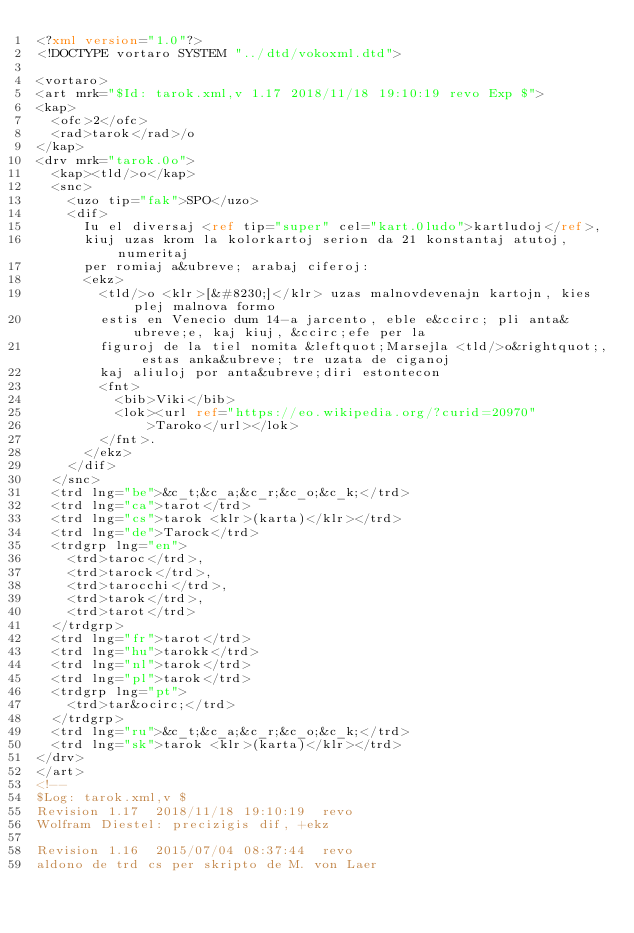Convert code to text. <code><loc_0><loc_0><loc_500><loc_500><_XML_><?xml version="1.0"?>
<!DOCTYPE vortaro SYSTEM "../dtd/vokoxml.dtd">

<vortaro>
<art mrk="$Id: tarok.xml,v 1.17 2018/11/18 19:10:19 revo Exp $">
<kap>
  <ofc>2</ofc>
  <rad>tarok</rad>/o
</kap>
<drv mrk="tarok.0o">
  <kap><tld/>o</kap>
  <snc>
    <uzo tip="fak">SPO</uzo>
    <dif>
      Iu el diversaj <ref tip="super" cel="kart.0ludo">kartludoj</ref>,
      kiuj uzas krom la kolorkartoj serion da 21 konstantaj atutoj, numeritaj
      per romiaj a&ubreve; arabaj ciferoj:
      <ekz>
        <tld/>o <klr>[&#8230;]</klr> uzas malnovdevenajn kartojn, kies plej malnova formo
        estis en Venecio dum 14-a jarcento, eble e&ccirc; pli anta&ubreve;e, kaj kiuj, &ccirc;efe per la
        figuroj de la tiel nomita &leftquot;Marsejla <tld/>o&rightquot;, estas anka&ubreve; tre uzata de ciganoj
        kaj aliuloj por anta&ubreve;diri estontecon
        <fnt>
          <bib>Viki</bib>
          <lok><url ref="https://eo.wikipedia.org/?curid=20970"
              >Taroko</url></lok>
        </fnt>.
      </ekz>
    </dif>
  </snc>
  <trd lng="be">&c_t;&c_a;&c_r;&c_o;&c_k;</trd>
  <trd lng="ca">tarot</trd>
  <trd lng="cs">tarok <klr>(karta)</klr></trd>
  <trd lng="de">Tarock</trd>
  <trdgrp lng="en">
    <trd>taroc</trd>,
    <trd>tarock</trd>,
    <trd>tarocchi</trd>,
    <trd>tarok</trd>,
    <trd>tarot</trd>
  </trdgrp>
  <trd lng="fr">tarot</trd>
  <trd lng="hu">tarokk</trd>
  <trd lng="nl">tarok</trd>
  <trd lng="pl">tarok</trd>
  <trdgrp lng="pt">
    <trd>tar&ocirc;</trd>
  </trdgrp>
  <trd lng="ru">&c_t;&c_a;&c_r;&c_o;&c_k;</trd>
  <trd lng="sk">tarok <klr>(karta)</klr></trd>
</drv>
</art>
<!--
$Log: tarok.xml,v $
Revision 1.17  2018/11/18 19:10:19  revo
Wolfram Diestel: precizigis dif, +ekz

Revision 1.16  2015/07/04 08:37:44  revo
aldono de trd cs per skripto de M. von Laer
</code> 